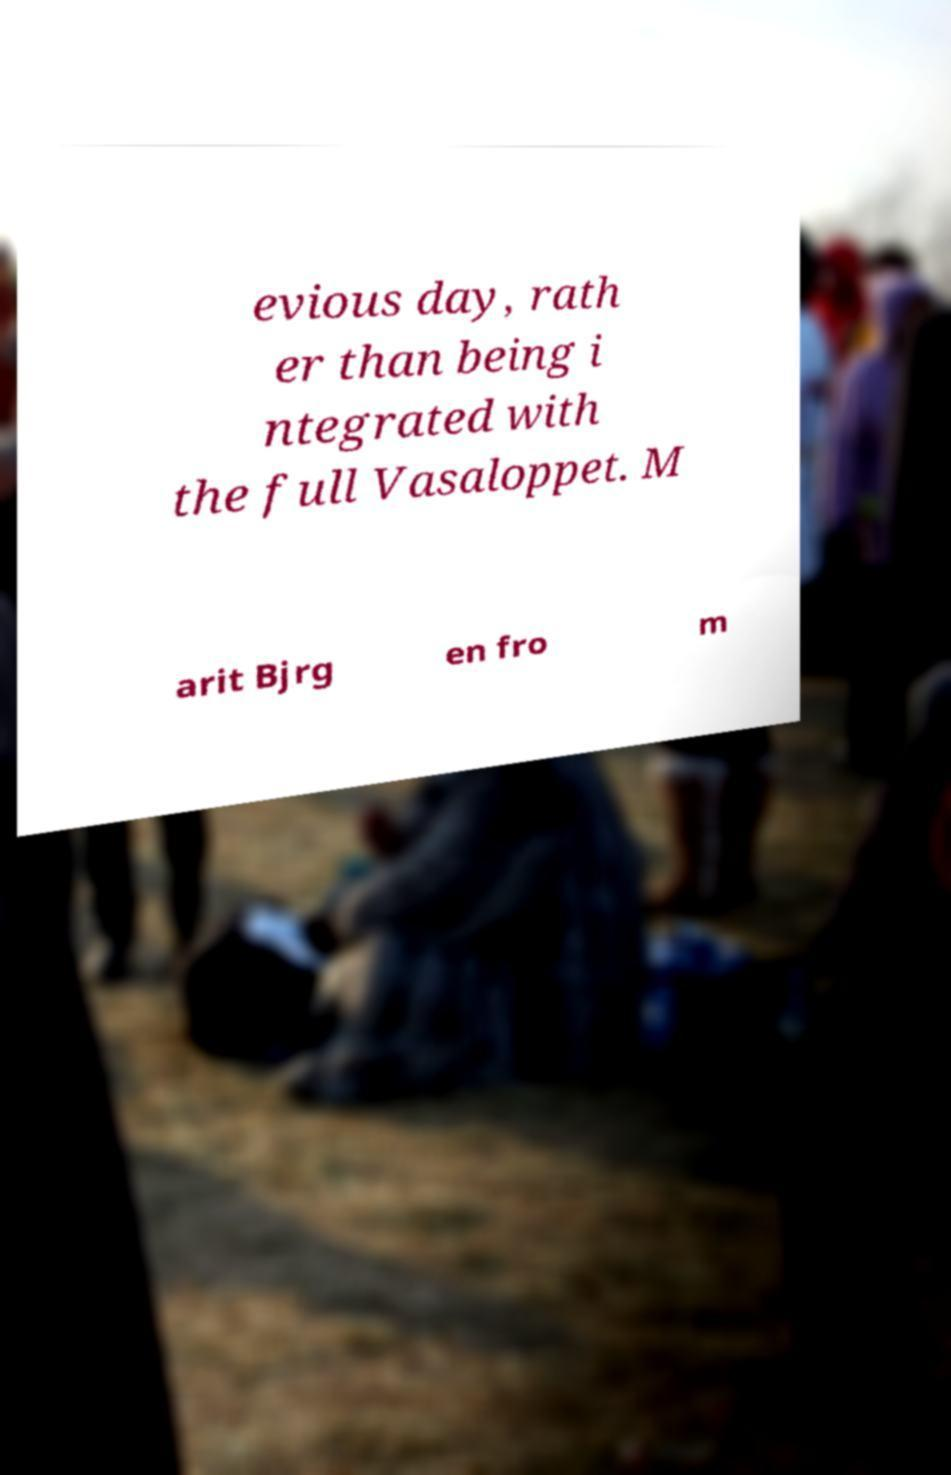Can you read and provide the text displayed in the image?This photo seems to have some interesting text. Can you extract and type it out for me? evious day, rath er than being i ntegrated with the full Vasaloppet. M arit Bjrg en fro m 